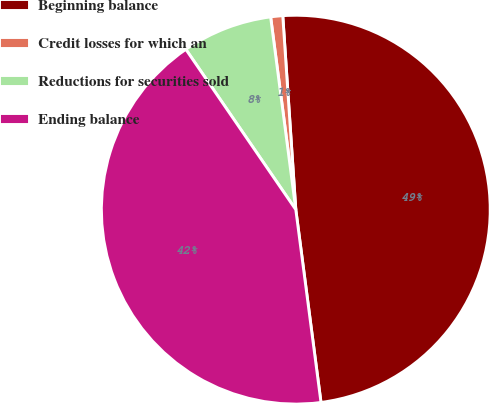<chart> <loc_0><loc_0><loc_500><loc_500><pie_chart><fcel>Beginning balance<fcel>Credit losses for which an<fcel>Reductions for securities sold<fcel>Ending balance<nl><fcel>49.0%<fcel>1.0%<fcel>7.5%<fcel>42.5%<nl></chart> 